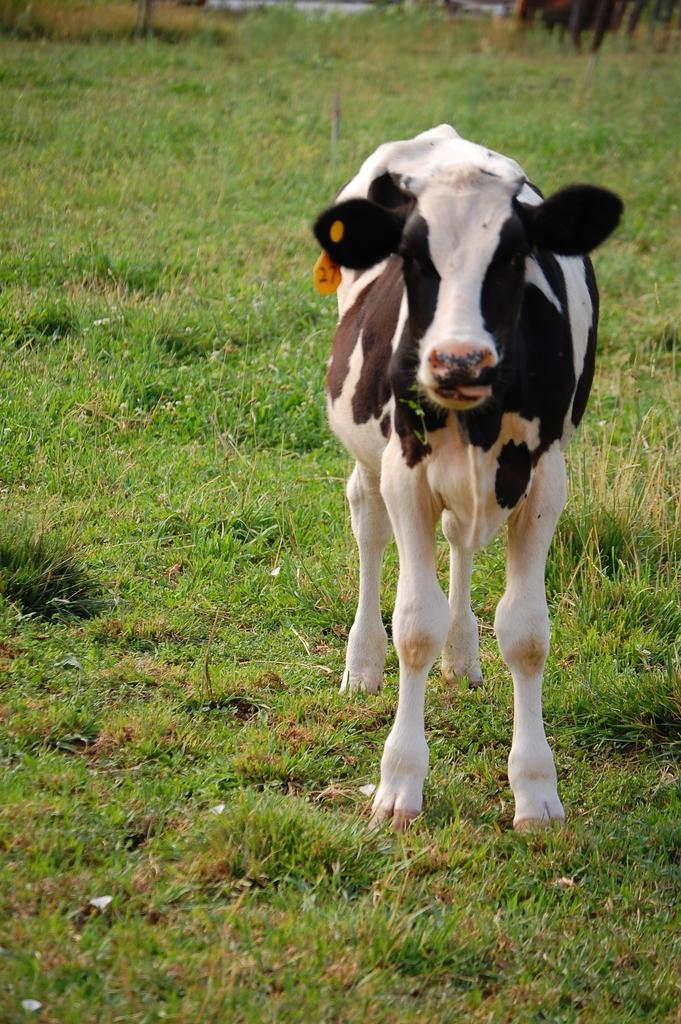What animal is present in the image? There is a cow in the image. What is the cow's position in the image? The cow is standing on the ground. What type of vegetation is visible at the bottom of the image? There is green grass at the bottom of the image. What color scheme is used for the cow in the image? The cow is in black and white color. What religious symbol can be seen hanging from the cow's neck in the image? There is no religious symbol hanging from the cow's neck in the image; it is a cow standing on green grass. 